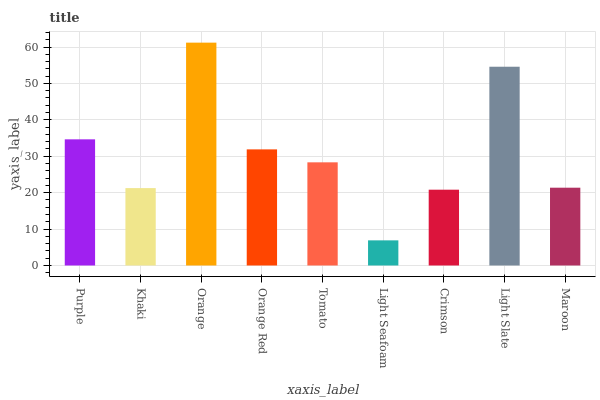Is Light Seafoam the minimum?
Answer yes or no. Yes. Is Orange the maximum?
Answer yes or no. Yes. Is Khaki the minimum?
Answer yes or no. No. Is Khaki the maximum?
Answer yes or no. No. Is Purple greater than Khaki?
Answer yes or no. Yes. Is Khaki less than Purple?
Answer yes or no. Yes. Is Khaki greater than Purple?
Answer yes or no. No. Is Purple less than Khaki?
Answer yes or no. No. Is Tomato the high median?
Answer yes or no. Yes. Is Tomato the low median?
Answer yes or no. Yes. Is Khaki the high median?
Answer yes or no. No. Is Crimson the low median?
Answer yes or no. No. 